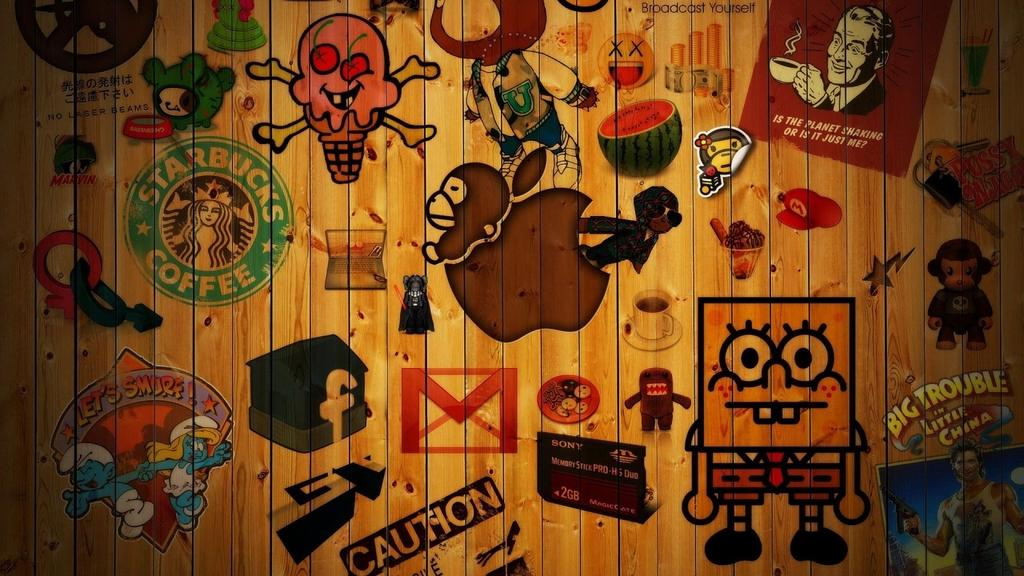What is depicted on the wooden wall in the image? There is a painting on a wooden wall in the image. What can be found within the painting? There is text and cartoons in the painting. What type of treatment is being administered to the kite in the image? There is no kite present in the image, so no treatment can be administered to it. 